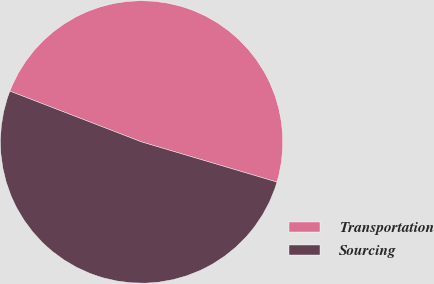<chart> <loc_0><loc_0><loc_500><loc_500><pie_chart><fcel>Transportation<fcel>Sourcing<nl><fcel>48.73%<fcel>51.27%<nl></chart> 